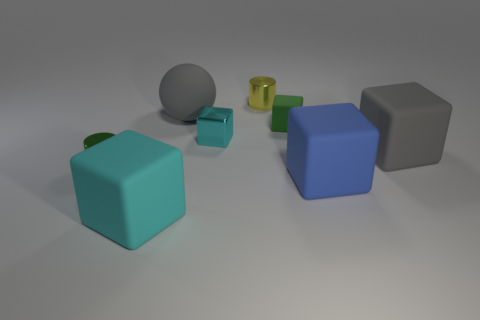Subtract all blue cylinders. Subtract all cyan balls. How many cylinders are left? 2 Subtract all purple spheres. How many blue cylinders are left? 0 Add 3 tiny grays. How many big blues exist? 0 Subtract all small green cylinders. Subtract all large blue cubes. How many objects are left? 6 Add 2 cyan rubber cubes. How many cyan rubber cubes are left? 3 Add 8 cyan matte blocks. How many cyan matte blocks exist? 9 Add 1 tiny gray cylinders. How many objects exist? 9 Subtract all gray blocks. How many blocks are left? 4 Subtract all small metallic blocks. How many blocks are left? 4 Subtract 1 yellow cylinders. How many objects are left? 7 